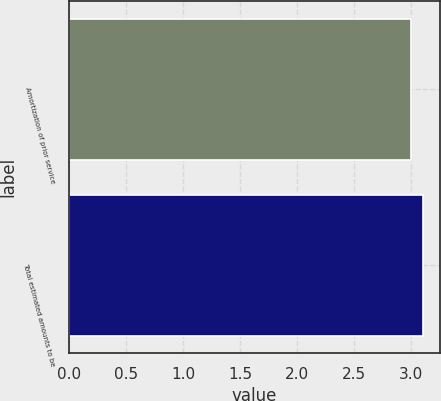Convert chart. <chart><loc_0><loc_0><loc_500><loc_500><bar_chart><fcel>Amortization of prior service<fcel>Total estimated amounts to be<nl><fcel>3<fcel>3.1<nl></chart> 